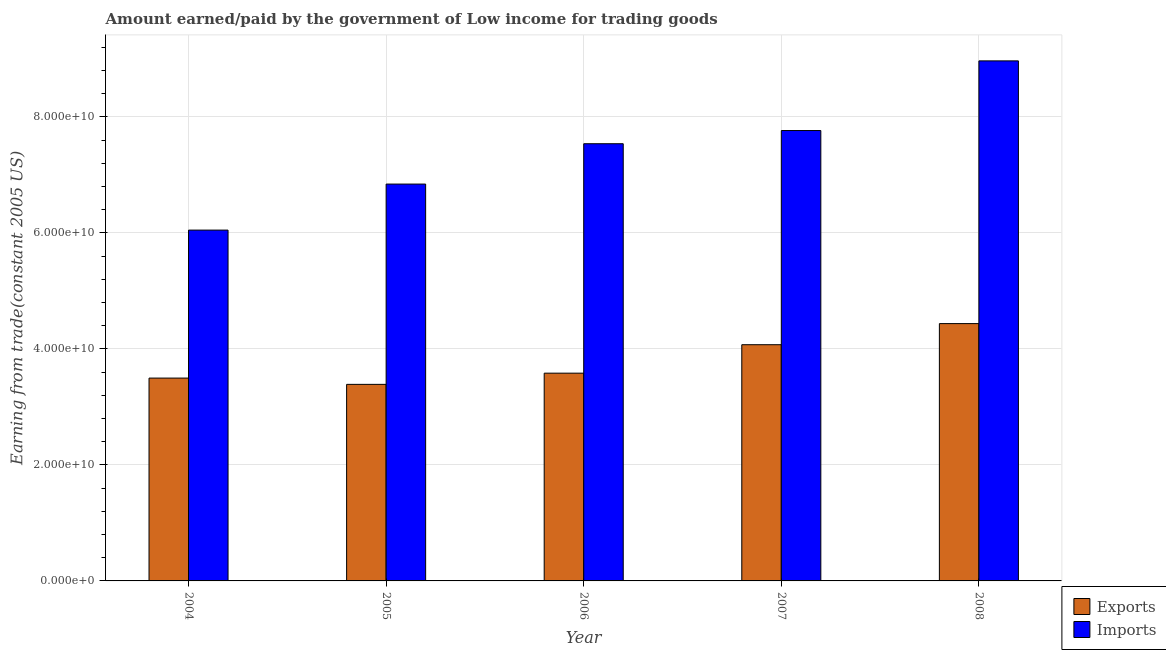How many bars are there on the 2nd tick from the right?
Make the answer very short. 2. What is the label of the 5th group of bars from the left?
Offer a very short reply. 2008. In how many cases, is the number of bars for a given year not equal to the number of legend labels?
Make the answer very short. 0. What is the amount paid for imports in 2006?
Your answer should be compact. 7.54e+1. Across all years, what is the maximum amount paid for imports?
Ensure brevity in your answer.  8.96e+1. Across all years, what is the minimum amount earned from exports?
Give a very brief answer. 3.39e+1. In which year was the amount earned from exports maximum?
Your response must be concise. 2008. What is the total amount paid for imports in the graph?
Your answer should be very brief. 3.72e+11. What is the difference between the amount paid for imports in 2005 and that in 2008?
Offer a very short reply. -2.12e+1. What is the difference between the amount paid for imports in 2004 and the amount earned from exports in 2007?
Offer a terse response. -1.72e+1. What is the average amount paid for imports per year?
Your answer should be very brief. 7.43e+1. In the year 2004, what is the difference between the amount paid for imports and amount earned from exports?
Make the answer very short. 0. What is the ratio of the amount earned from exports in 2004 to that in 2007?
Offer a very short reply. 0.86. What is the difference between the highest and the second highest amount earned from exports?
Your response must be concise. 3.64e+09. What is the difference between the highest and the lowest amount earned from exports?
Your answer should be compact. 1.05e+1. What does the 1st bar from the left in 2008 represents?
Your answer should be compact. Exports. What does the 1st bar from the right in 2006 represents?
Your answer should be very brief. Imports. How many bars are there?
Provide a short and direct response. 10. Does the graph contain any zero values?
Provide a short and direct response. No. Does the graph contain grids?
Your response must be concise. Yes. Where does the legend appear in the graph?
Your answer should be very brief. Bottom right. What is the title of the graph?
Make the answer very short. Amount earned/paid by the government of Low income for trading goods. Does "Agricultural land" appear as one of the legend labels in the graph?
Offer a terse response. No. What is the label or title of the Y-axis?
Offer a terse response. Earning from trade(constant 2005 US). What is the Earning from trade(constant 2005 US) in Exports in 2004?
Offer a terse response. 3.50e+1. What is the Earning from trade(constant 2005 US) in Imports in 2004?
Provide a short and direct response. 6.05e+1. What is the Earning from trade(constant 2005 US) in Exports in 2005?
Your answer should be compact. 3.39e+1. What is the Earning from trade(constant 2005 US) of Imports in 2005?
Your answer should be very brief. 6.84e+1. What is the Earning from trade(constant 2005 US) in Exports in 2006?
Provide a succinct answer. 3.58e+1. What is the Earning from trade(constant 2005 US) in Imports in 2006?
Give a very brief answer. 7.54e+1. What is the Earning from trade(constant 2005 US) of Exports in 2007?
Offer a very short reply. 4.07e+1. What is the Earning from trade(constant 2005 US) of Imports in 2007?
Keep it short and to the point. 7.76e+1. What is the Earning from trade(constant 2005 US) in Exports in 2008?
Provide a short and direct response. 4.44e+1. What is the Earning from trade(constant 2005 US) of Imports in 2008?
Keep it short and to the point. 8.96e+1. Across all years, what is the maximum Earning from trade(constant 2005 US) in Exports?
Provide a succinct answer. 4.44e+1. Across all years, what is the maximum Earning from trade(constant 2005 US) of Imports?
Offer a very short reply. 8.96e+1. Across all years, what is the minimum Earning from trade(constant 2005 US) of Exports?
Offer a very short reply. 3.39e+1. Across all years, what is the minimum Earning from trade(constant 2005 US) of Imports?
Give a very brief answer. 6.05e+1. What is the total Earning from trade(constant 2005 US) in Exports in the graph?
Offer a very short reply. 1.90e+11. What is the total Earning from trade(constant 2005 US) of Imports in the graph?
Provide a short and direct response. 3.72e+11. What is the difference between the Earning from trade(constant 2005 US) of Exports in 2004 and that in 2005?
Make the answer very short. 1.08e+09. What is the difference between the Earning from trade(constant 2005 US) in Imports in 2004 and that in 2005?
Your answer should be compact. -7.93e+09. What is the difference between the Earning from trade(constant 2005 US) in Exports in 2004 and that in 2006?
Give a very brief answer. -8.49e+08. What is the difference between the Earning from trade(constant 2005 US) of Imports in 2004 and that in 2006?
Your response must be concise. -1.49e+1. What is the difference between the Earning from trade(constant 2005 US) in Exports in 2004 and that in 2007?
Your response must be concise. -5.75e+09. What is the difference between the Earning from trade(constant 2005 US) in Imports in 2004 and that in 2007?
Keep it short and to the point. -1.72e+1. What is the difference between the Earning from trade(constant 2005 US) of Exports in 2004 and that in 2008?
Keep it short and to the point. -9.39e+09. What is the difference between the Earning from trade(constant 2005 US) of Imports in 2004 and that in 2008?
Ensure brevity in your answer.  -2.92e+1. What is the difference between the Earning from trade(constant 2005 US) of Exports in 2005 and that in 2006?
Ensure brevity in your answer.  -1.93e+09. What is the difference between the Earning from trade(constant 2005 US) of Imports in 2005 and that in 2006?
Ensure brevity in your answer.  -6.96e+09. What is the difference between the Earning from trade(constant 2005 US) of Exports in 2005 and that in 2007?
Ensure brevity in your answer.  -6.84e+09. What is the difference between the Earning from trade(constant 2005 US) of Imports in 2005 and that in 2007?
Ensure brevity in your answer.  -9.23e+09. What is the difference between the Earning from trade(constant 2005 US) of Exports in 2005 and that in 2008?
Your response must be concise. -1.05e+1. What is the difference between the Earning from trade(constant 2005 US) in Imports in 2005 and that in 2008?
Your answer should be compact. -2.12e+1. What is the difference between the Earning from trade(constant 2005 US) of Exports in 2006 and that in 2007?
Your response must be concise. -4.90e+09. What is the difference between the Earning from trade(constant 2005 US) in Imports in 2006 and that in 2007?
Keep it short and to the point. -2.27e+09. What is the difference between the Earning from trade(constant 2005 US) of Exports in 2006 and that in 2008?
Give a very brief answer. -8.54e+09. What is the difference between the Earning from trade(constant 2005 US) of Imports in 2006 and that in 2008?
Your answer should be very brief. -1.43e+1. What is the difference between the Earning from trade(constant 2005 US) in Exports in 2007 and that in 2008?
Make the answer very short. -3.64e+09. What is the difference between the Earning from trade(constant 2005 US) in Imports in 2007 and that in 2008?
Offer a very short reply. -1.20e+1. What is the difference between the Earning from trade(constant 2005 US) of Exports in 2004 and the Earning from trade(constant 2005 US) of Imports in 2005?
Keep it short and to the point. -3.34e+1. What is the difference between the Earning from trade(constant 2005 US) in Exports in 2004 and the Earning from trade(constant 2005 US) in Imports in 2006?
Make the answer very short. -4.04e+1. What is the difference between the Earning from trade(constant 2005 US) of Exports in 2004 and the Earning from trade(constant 2005 US) of Imports in 2007?
Make the answer very short. -4.27e+1. What is the difference between the Earning from trade(constant 2005 US) of Exports in 2004 and the Earning from trade(constant 2005 US) of Imports in 2008?
Make the answer very short. -5.47e+1. What is the difference between the Earning from trade(constant 2005 US) in Exports in 2005 and the Earning from trade(constant 2005 US) in Imports in 2006?
Offer a very short reply. -4.15e+1. What is the difference between the Earning from trade(constant 2005 US) in Exports in 2005 and the Earning from trade(constant 2005 US) in Imports in 2007?
Give a very brief answer. -4.38e+1. What is the difference between the Earning from trade(constant 2005 US) in Exports in 2005 and the Earning from trade(constant 2005 US) in Imports in 2008?
Offer a very short reply. -5.58e+1. What is the difference between the Earning from trade(constant 2005 US) of Exports in 2006 and the Earning from trade(constant 2005 US) of Imports in 2007?
Keep it short and to the point. -4.18e+1. What is the difference between the Earning from trade(constant 2005 US) in Exports in 2006 and the Earning from trade(constant 2005 US) in Imports in 2008?
Keep it short and to the point. -5.38e+1. What is the difference between the Earning from trade(constant 2005 US) in Exports in 2007 and the Earning from trade(constant 2005 US) in Imports in 2008?
Make the answer very short. -4.89e+1. What is the average Earning from trade(constant 2005 US) of Exports per year?
Keep it short and to the point. 3.79e+1. What is the average Earning from trade(constant 2005 US) in Imports per year?
Your answer should be very brief. 7.43e+1. In the year 2004, what is the difference between the Earning from trade(constant 2005 US) of Exports and Earning from trade(constant 2005 US) of Imports?
Your answer should be compact. -2.55e+1. In the year 2005, what is the difference between the Earning from trade(constant 2005 US) in Exports and Earning from trade(constant 2005 US) in Imports?
Ensure brevity in your answer.  -3.45e+1. In the year 2006, what is the difference between the Earning from trade(constant 2005 US) in Exports and Earning from trade(constant 2005 US) in Imports?
Provide a succinct answer. -3.95e+1. In the year 2007, what is the difference between the Earning from trade(constant 2005 US) in Exports and Earning from trade(constant 2005 US) in Imports?
Your answer should be compact. -3.69e+1. In the year 2008, what is the difference between the Earning from trade(constant 2005 US) of Exports and Earning from trade(constant 2005 US) of Imports?
Your answer should be very brief. -4.53e+1. What is the ratio of the Earning from trade(constant 2005 US) in Exports in 2004 to that in 2005?
Your answer should be very brief. 1.03. What is the ratio of the Earning from trade(constant 2005 US) in Imports in 2004 to that in 2005?
Your answer should be very brief. 0.88. What is the ratio of the Earning from trade(constant 2005 US) in Exports in 2004 to that in 2006?
Provide a short and direct response. 0.98. What is the ratio of the Earning from trade(constant 2005 US) in Imports in 2004 to that in 2006?
Provide a short and direct response. 0.8. What is the ratio of the Earning from trade(constant 2005 US) in Exports in 2004 to that in 2007?
Make the answer very short. 0.86. What is the ratio of the Earning from trade(constant 2005 US) of Imports in 2004 to that in 2007?
Provide a short and direct response. 0.78. What is the ratio of the Earning from trade(constant 2005 US) in Exports in 2004 to that in 2008?
Provide a short and direct response. 0.79. What is the ratio of the Earning from trade(constant 2005 US) of Imports in 2004 to that in 2008?
Give a very brief answer. 0.67. What is the ratio of the Earning from trade(constant 2005 US) of Exports in 2005 to that in 2006?
Ensure brevity in your answer.  0.95. What is the ratio of the Earning from trade(constant 2005 US) in Imports in 2005 to that in 2006?
Your answer should be compact. 0.91. What is the ratio of the Earning from trade(constant 2005 US) of Exports in 2005 to that in 2007?
Provide a short and direct response. 0.83. What is the ratio of the Earning from trade(constant 2005 US) of Imports in 2005 to that in 2007?
Your response must be concise. 0.88. What is the ratio of the Earning from trade(constant 2005 US) in Exports in 2005 to that in 2008?
Make the answer very short. 0.76. What is the ratio of the Earning from trade(constant 2005 US) in Imports in 2005 to that in 2008?
Make the answer very short. 0.76. What is the ratio of the Earning from trade(constant 2005 US) in Exports in 2006 to that in 2007?
Your answer should be very brief. 0.88. What is the ratio of the Earning from trade(constant 2005 US) in Imports in 2006 to that in 2007?
Ensure brevity in your answer.  0.97. What is the ratio of the Earning from trade(constant 2005 US) of Exports in 2006 to that in 2008?
Ensure brevity in your answer.  0.81. What is the ratio of the Earning from trade(constant 2005 US) in Imports in 2006 to that in 2008?
Make the answer very short. 0.84. What is the ratio of the Earning from trade(constant 2005 US) in Exports in 2007 to that in 2008?
Ensure brevity in your answer.  0.92. What is the ratio of the Earning from trade(constant 2005 US) in Imports in 2007 to that in 2008?
Offer a terse response. 0.87. What is the difference between the highest and the second highest Earning from trade(constant 2005 US) of Exports?
Ensure brevity in your answer.  3.64e+09. What is the difference between the highest and the second highest Earning from trade(constant 2005 US) in Imports?
Your answer should be very brief. 1.20e+1. What is the difference between the highest and the lowest Earning from trade(constant 2005 US) in Exports?
Offer a terse response. 1.05e+1. What is the difference between the highest and the lowest Earning from trade(constant 2005 US) in Imports?
Provide a short and direct response. 2.92e+1. 